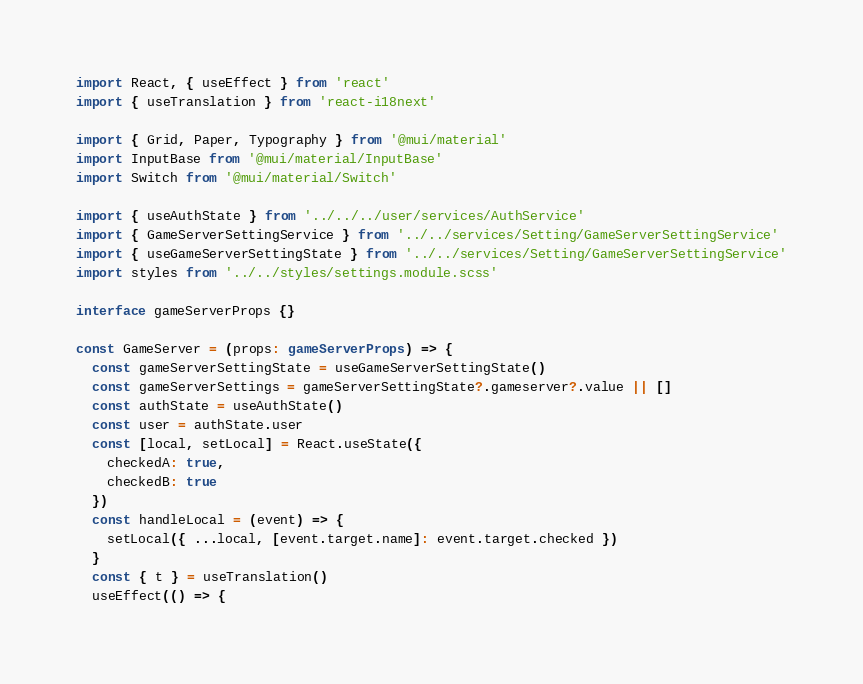Convert code to text. <code><loc_0><loc_0><loc_500><loc_500><_TypeScript_>import React, { useEffect } from 'react'
import { useTranslation } from 'react-i18next'

import { Grid, Paper, Typography } from '@mui/material'
import InputBase from '@mui/material/InputBase'
import Switch from '@mui/material/Switch'

import { useAuthState } from '../../../user/services/AuthService'
import { GameServerSettingService } from '../../services/Setting/GameServerSettingService'
import { useGameServerSettingState } from '../../services/Setting/GameServerSettingService'
import styles from '../../styles/settings.module.scss'

interface gameServerProps {}

const GameServer = (props: gameServerProps) => {
  const gameServerSettingState = useGameServerSettingState()
  const gameServerSettings = gameServerSettingState?.gameserver?.value || []
  const authState = useAuthState()
  const user = authState.user
  const [local, setLocal] = React.useState({
    checkedA: true,
    checkedB: true
  })
  const handleLocal = (event) => {
    setLocal({ ...local, [event.target.name]: event.target.checked })
  }
  const { t } = useTranslation()
  useEffect(() => {</code> 